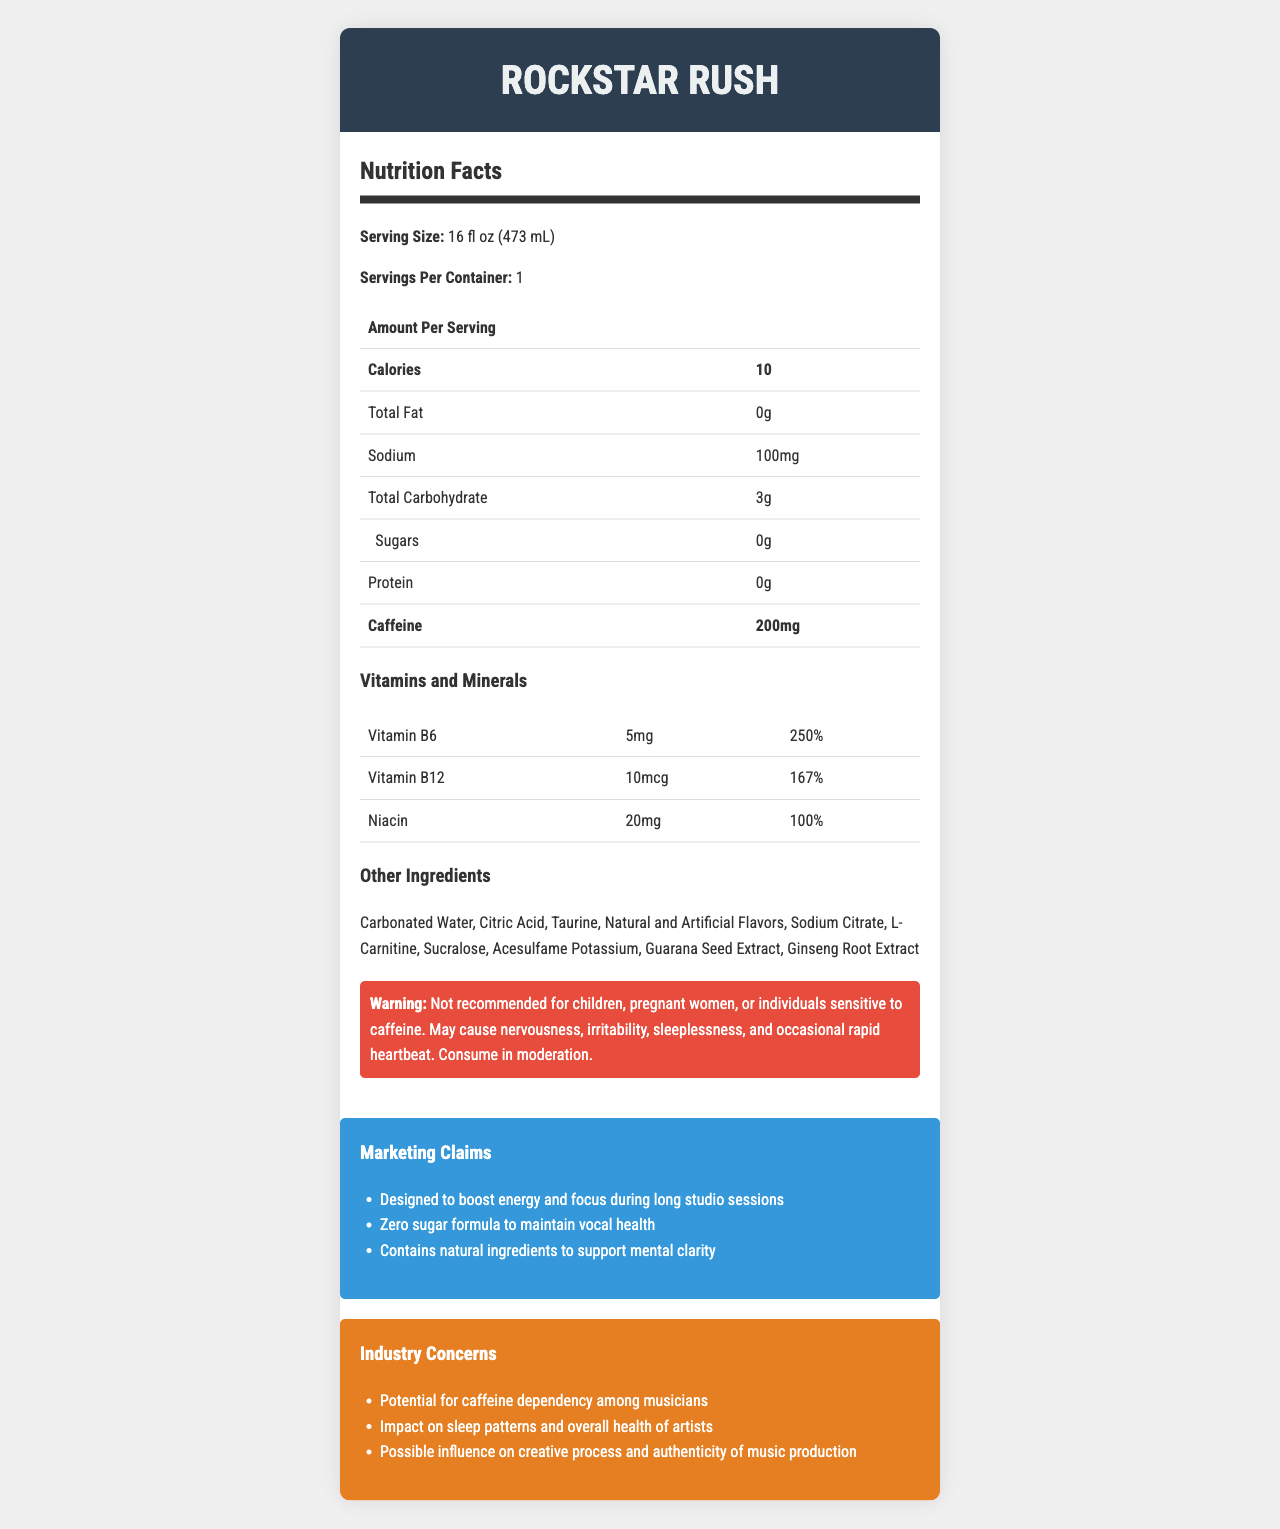what is the serving size of Rockstar Rush? The serving size is listed as "16 fl oz (473 mL)" in the document under the Nutrition Facts section.
Answer: 16 fl oz (473 mL) how many servings per container are there? The document indicates that there is 1 serving per container.
Answer: 1 what is the caffeine content in Rockstar Rush per serving? Under the Nutrition Facts section, it mentions that the amount of caffeine per serving is 200mg.
Answer: 200mg list some of the vitamins and minerals included in Rockstar Rush The document lists Vitamin B6, Vitamin B12, and Niacin among the vitamins and minerals included.
Answer: Vitamin B6, Vitamin B12, Niacin what are the potential side effects of consuming Rockstar Rush? In the warning statement, the document mentions these potential side effects.
Answer: Nervousness, irritability, sleeplessness, occasional rapid heartbeat what is the calorie content per serving? A. 5 B. 10 C. 50 D. 100 According to the Nutrition Facts section, Rockstar Rush contains 10 calories per serving.
Answer: B which of the following is NOT an ingredient in Rockstar Rush? I. Sucralose II. Aspartame III. Ginseng Root Extract IV. Taurine The ingredient list includes Sucralose, Ginseng Root Extract, and Taurine, but not Aspartame.
Answer: II is Rockstar Rush recommended for children? The warning statement clearly mentions that it is not recommended for children.
Answer: No summarize the main purpose and benefits of Rockstar Rush as marketed. The document highlights these claims under the Marketing Claims section: designed to boost energy and focus during long studio sessions, zero sugar formula to maintain vocal health, and contains natural ingredients to support mental clarity.
Answer: Rockstar Rush aims to boost energy and focus during long studio sessions, maintain vocal health with a zero-sugar formula, and support mental clarity with natural ingredients. what is the exact amount of sodium per serving in Rockstar Rush? The Nutrition Facts section specifies that the sodium content per serving is 100mg.
Answer: 100mg how might the caffeine content influence a musician's sleep patterns? The warning statement mentions sleeplessness as a potential side effect due to caffeine content, thereby affecting sleep patterns.
Answer: Caffeine can cause sleeplessness, affecting a musician's sleep patterns. what should pregnant women do regarding Rockstar Rush? The warning statement specifies that Rockstar Rush is not recommended for pregnant women.
Answer: They should not consume it. describe one of the industry concerns related to Rockstar Rush. Under Industry Concerns, it lists "Potential for caffeine dependency among musicians" as one of the concerns.
Answer: Potential for caffeine dependency among musicians what is the total carbohydrate content per serving? According to the Nutrition Facts section, the total carbohydrate content per serving is 3g.
Answer: 3g how does Rockstar Rush claim to support mental clarity? A. With caffeine B. With sucralose C. With natural ingredients D. With citric acid The Marketing Claims section mentions that Rockstar Rush contains natural ingredients to support mental clarity, making "With natural ingredients" the correct answer.
Answer: C does Rockstar Rush contain any sugars? The document states that the sugar content is 0g.
Answer: No is there enough information to determine the effect of Rockstar Rush on a musician's creative process? The Industry Concerns mention potential influence on the creative process, but there's no detailed information provided to determine the exact effect.
Answer: No 